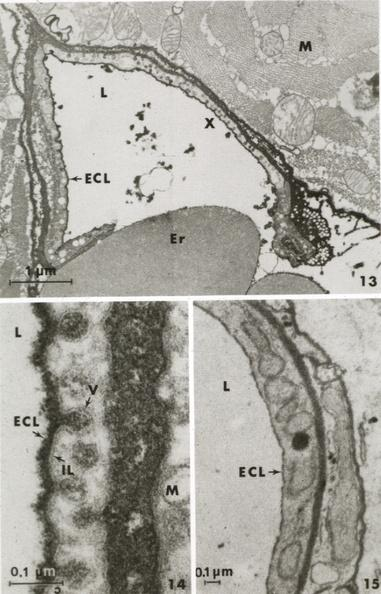where is this mage from?
Answer the question using a single word or phrase. Capillary 